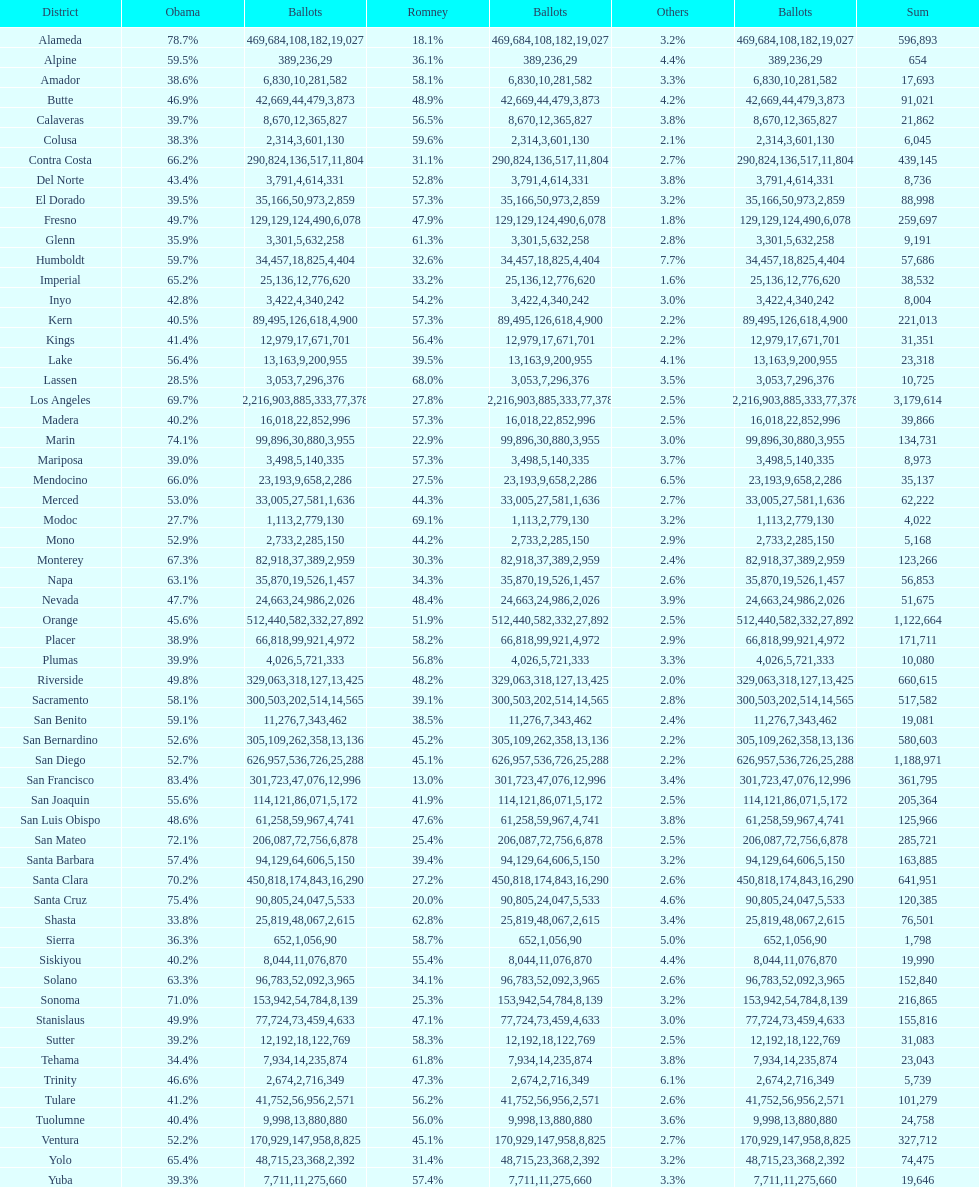Which county had the most total votes? Los Angeles. 